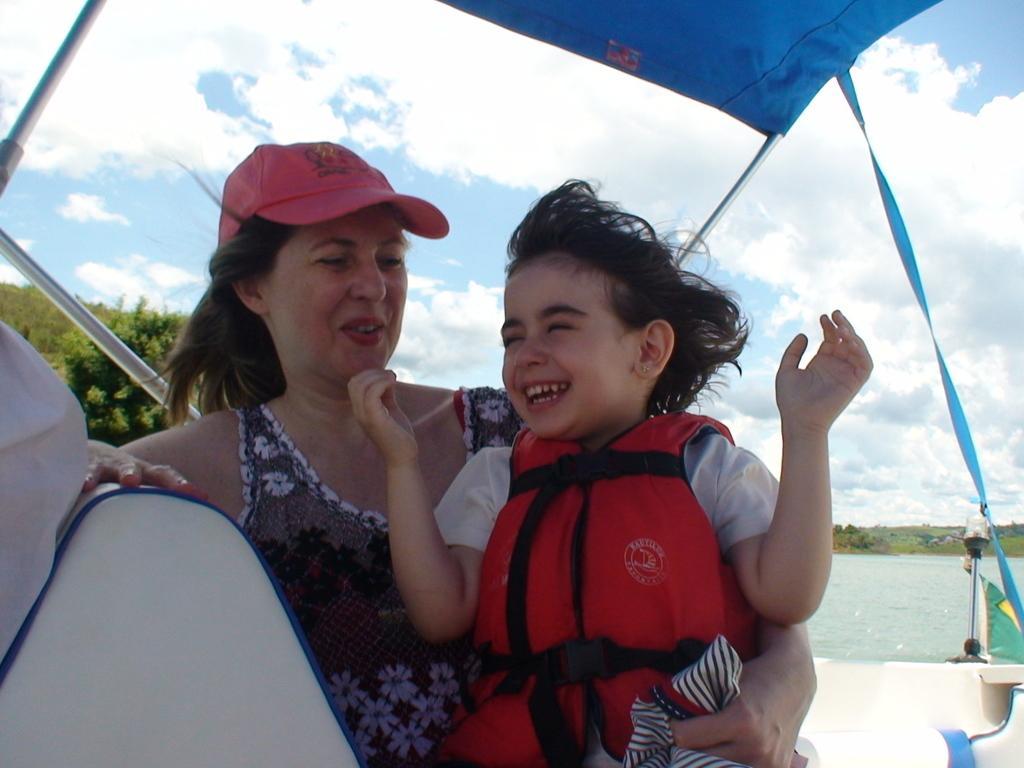Can you describe this image briefly? In this image we can see a woman holding a child. We can also see a tent with some poles. On the backside we can see a water body, a group of trees and the sky which looks cloudy. 